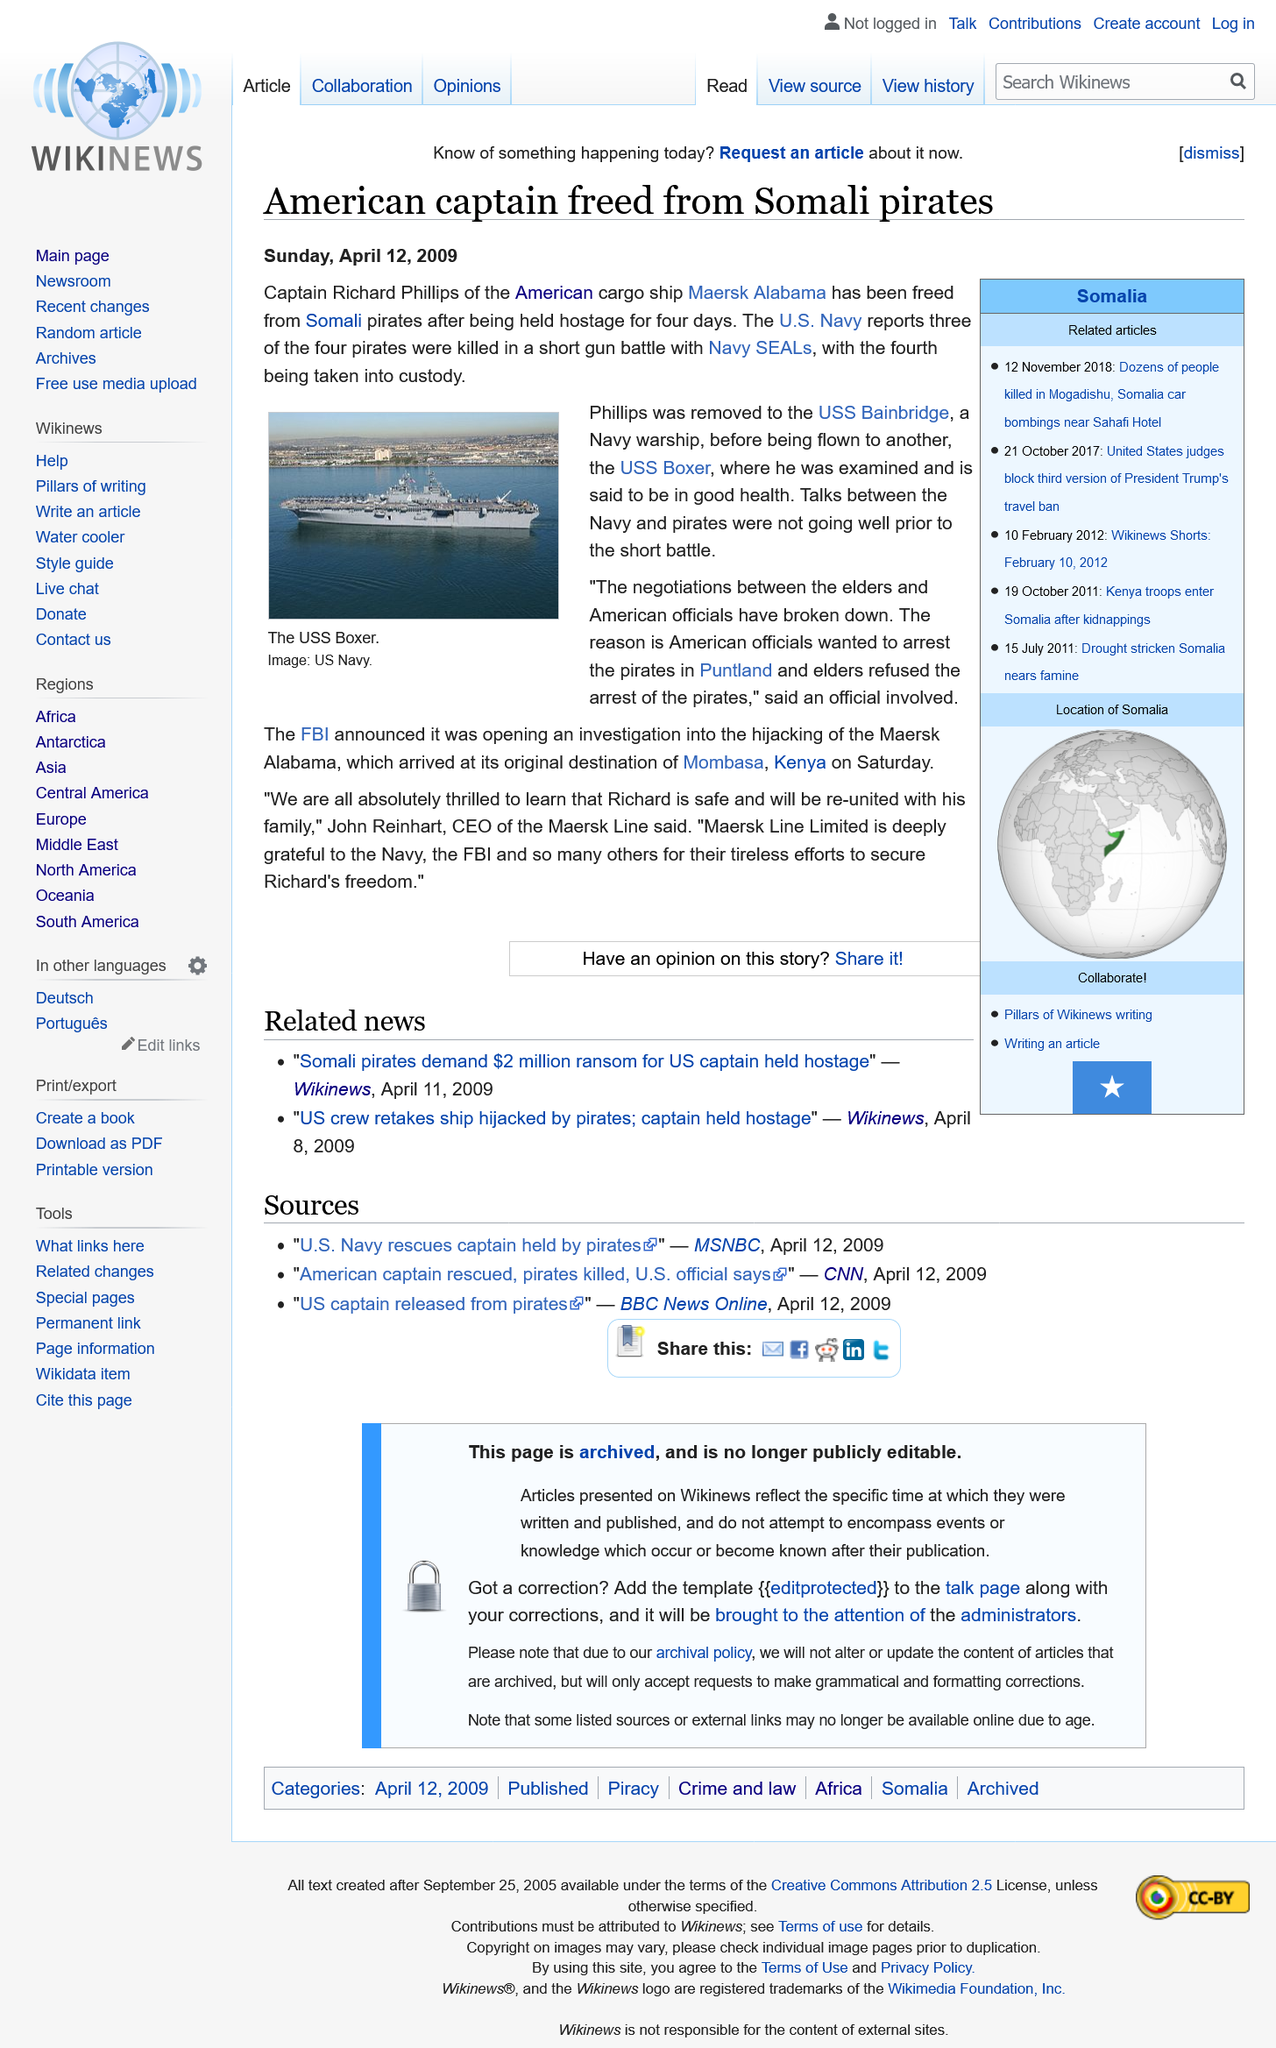List a handful of essential elements in this visual. Captain Richard Philips was held captive for a period of four days. The picture depicts the USS Boxer, as it is portrayed in the image. 